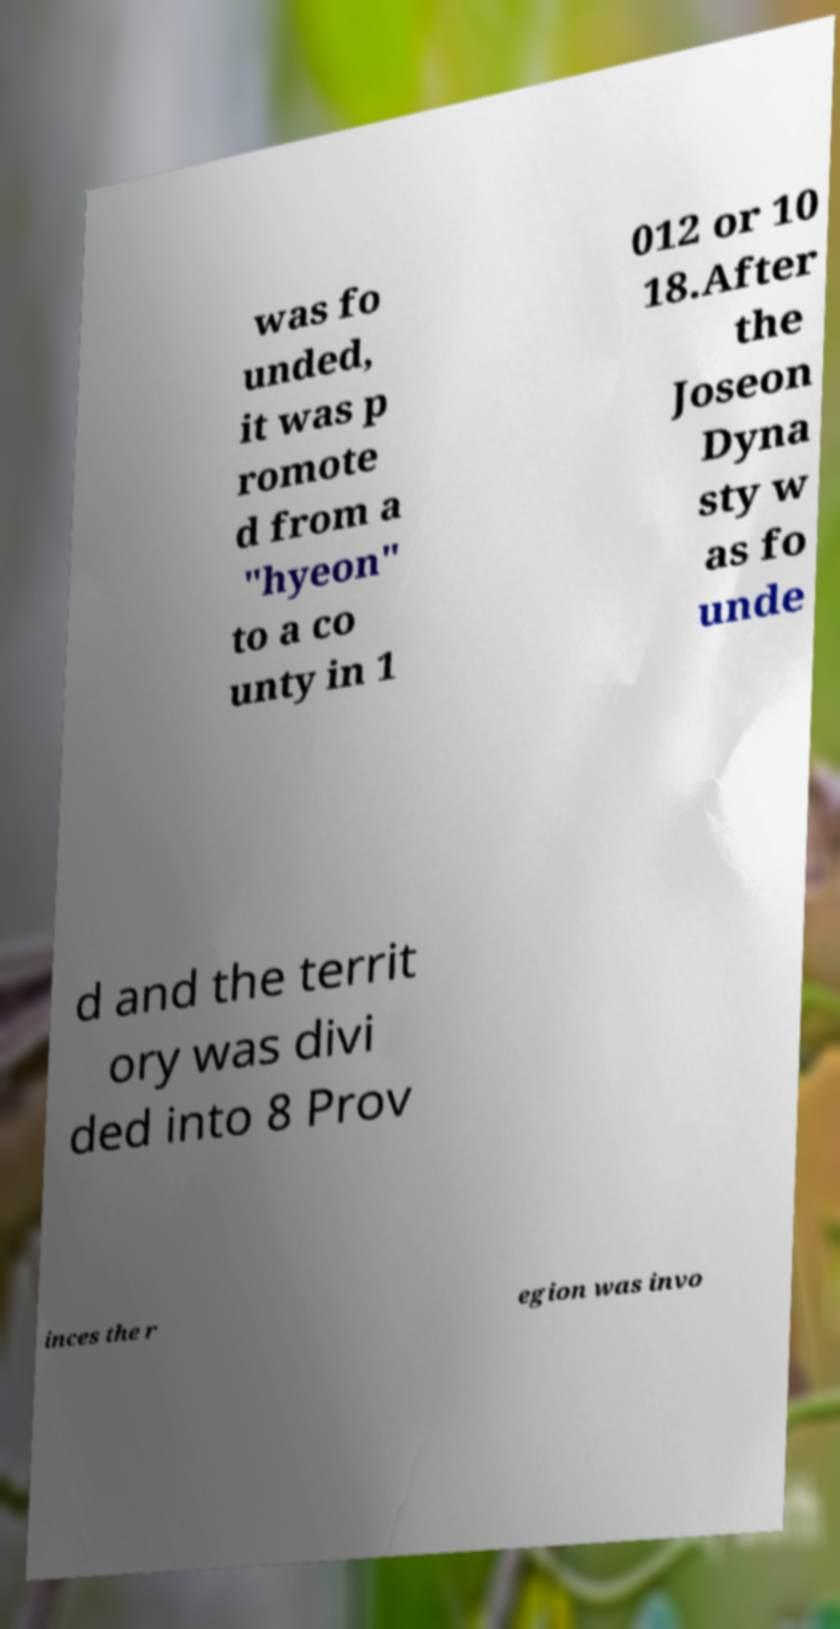Could you assist in decoding the text presented in this image and type it out clearly? was fo unded, it was p romote d from a "hyeon" to a co unty in 1 012 or 10 18.After the Joseon Dyna sty w as fo unde d and the territ ory was divi ded into 8 Prov inces the r egion was invo 